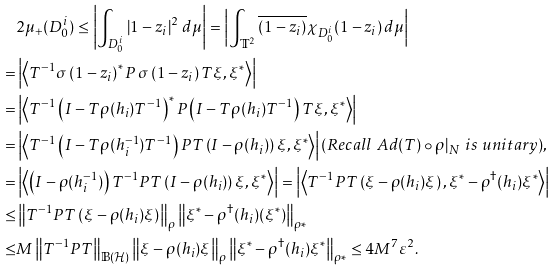<formula> <loc_0><loc_0><loc_500><loc_500>& 2 \mu _ { + } ( D _ { 0 } ^ { i } ) \leq \left | \int _ { D _ { 0 } ^ { i } } \left | 1 - z _ { i } \right | ^ { 2 } \, d \mu \right | = \left | \int _ { \mathbb { T } ^ { 2 } } \overline { \left ( 1 - z _ { i } \right ) } \chi _ { D _ { 0 } ^ { i } } ( 1 - z _ { i } ) \, d \mu \right | \\ = & \left | \left \langle T ^ { - 1 } \sigma \left ( 1 - z _ { i } \right ) ^ { * } P \, \sigma \left ( 1 - z _ { i } \right ) T \xi , \xi ^ { * } \right \rangle \right | \\ = & \left | \left \langle T ^ { - 1 } \left ( I - T \rho ( h _ { i } ) T ^ { - 1 } \right ) ^ { * } P \left ( I - T \rho ( h _ { i } ) T ^ { - 1 } \right ) T \xi , \xi ^ { * } \right \rangle \right | \\ = & \left | \left \langle T ^ { - 1 } \left ( I - T \rho ( h _ { i } ^ { - 1 } ) T ^ { - 1 } \right ) P T \left ( I - \rho ( h _ { i } ) \right ) \xi , \xi ^ { * } \right \rangle \right | ( R e c a l l \ A d ( T ) \circ \rho | _ { N } \ i s \ u n i t a r y ) , \\ = & \left | \left \langle \left ( I - \rho ( h _ { i } ^ { - 1 } ) \right ) T ^ { - 1 } P T \left ( I - \rho ( h _ { i } ) \right ) \xi , \xi ^ { * } \right \rangle \right | = \left | \left \langle T ^ { - 1 } P T \left ( \xi - \rho ( h _ { i } ) \xi \right ) , \xi ^ { * } - \rho ^ { \dagger } ( h _ { i } ) \xi ^ { * } \right \rangle \right | \\ \leq & \left \| T ^ { - 1 } P T \left ( \xi - \rho ( h _ { i } ) \xi \right ) \right \| _ { \rho } \left \| \xi ^ { * } - \rho ^ { \dagger } ( h _ { i } ) ( \xi ^ { * } ) \right \| _ { \rho * } \\ \leq & M \left \| T ^ { - 1 } P T \right \| _ { \mathbb { B } ( \mathcal { H } ) } \left \| \xi - \rho ( h _ { i } ) \xi \right \| _ { \rho } \left \| \xi ^ { * } - \rho ^ { \dagger } ( h _ { i } ) \xi ^ { * } \right \| _ { \rho * } \leq 4 M ^ { 7 } \varepsilon ^ { 2 } .</formula> 